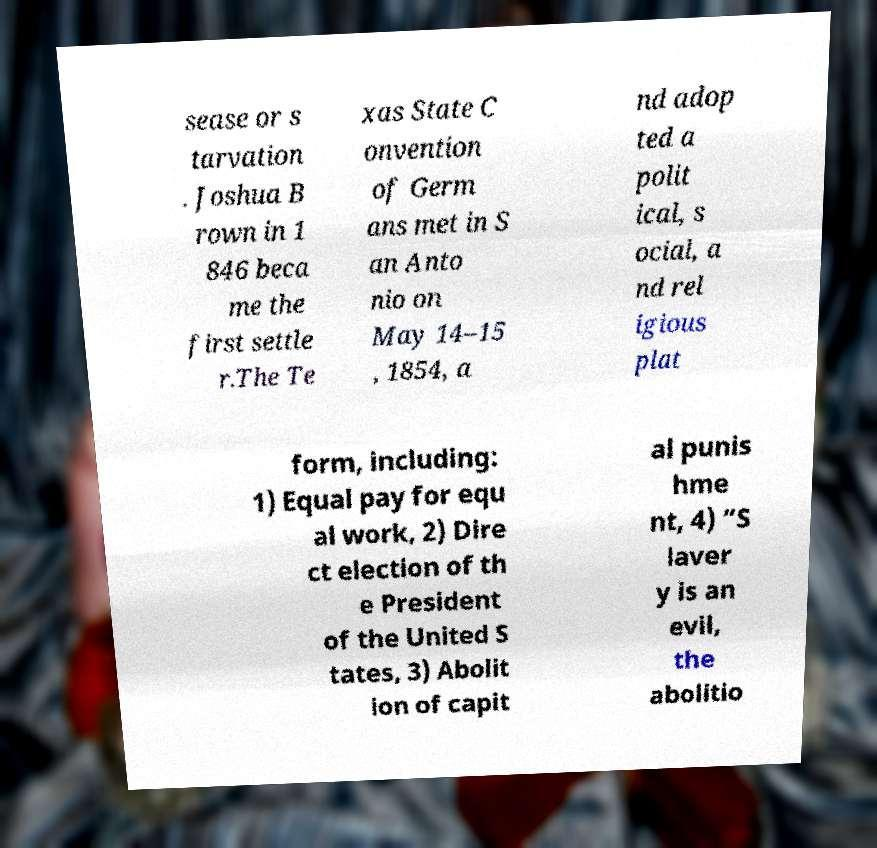What messages or text are displayed in this image? I need them in a readable, typed format. sease or s tarvation . Joshua B rown in 1 846 beca me the first settle r.The Te xas State C onvention of Germ ans met in S an Anto nio on May 14–15 , 1854, a nd adop ted a polit ical, s ocial, a nd rel igious plat form, including: 1) Equal pay for equ al work, 2) Dire ct election of th e President of the United S tates, 3) Abolit ion of capit al punis hme nt, 4) “S laver y is an evil, the abolitio 